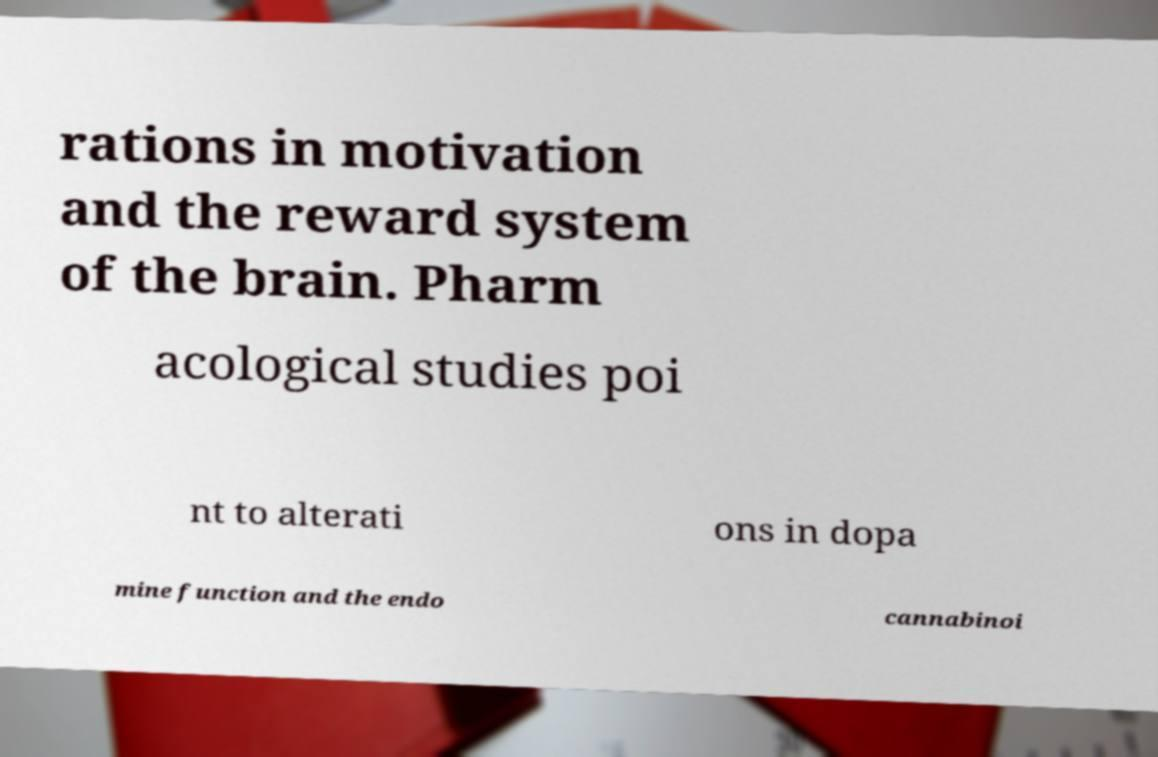I need the written content from this picture converted into text. Can you do that? rations in motivation and the reward system of the brain. Pharm acological studies poi nt to alterati ons in dopa mine function and the endo cannabinoi 